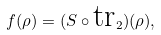Convert formula to latex. <formula><loc_0><loc_0><loc_500><loc_500>f ( \rho ) = ( S \circ \text {tr} _ { 2 } ) ( \rho ) ,</formula> 